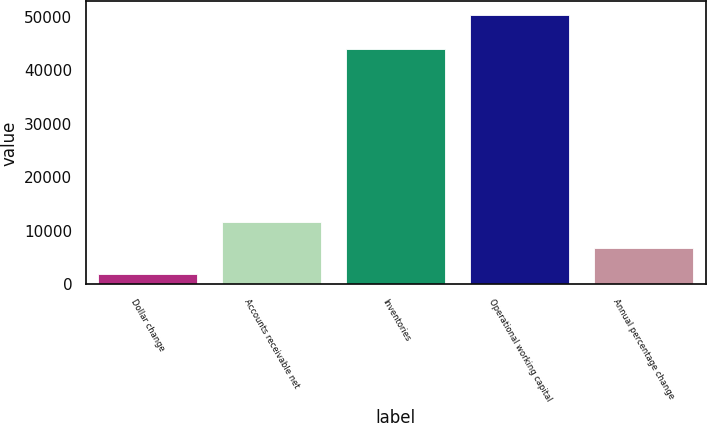<chart> <loc_0><loc_0><loc_500><loc_500><bar_chart><fcel>Dollar change<fcel>Accounts receivable net<fcel>Inventories<fcel>Operational working capital<fcel>Annual percentage change<nl><fcel>2015<fcel>11679.4<fcel>44039<fcel>50337<fcel>6847.2<nl></chart> 